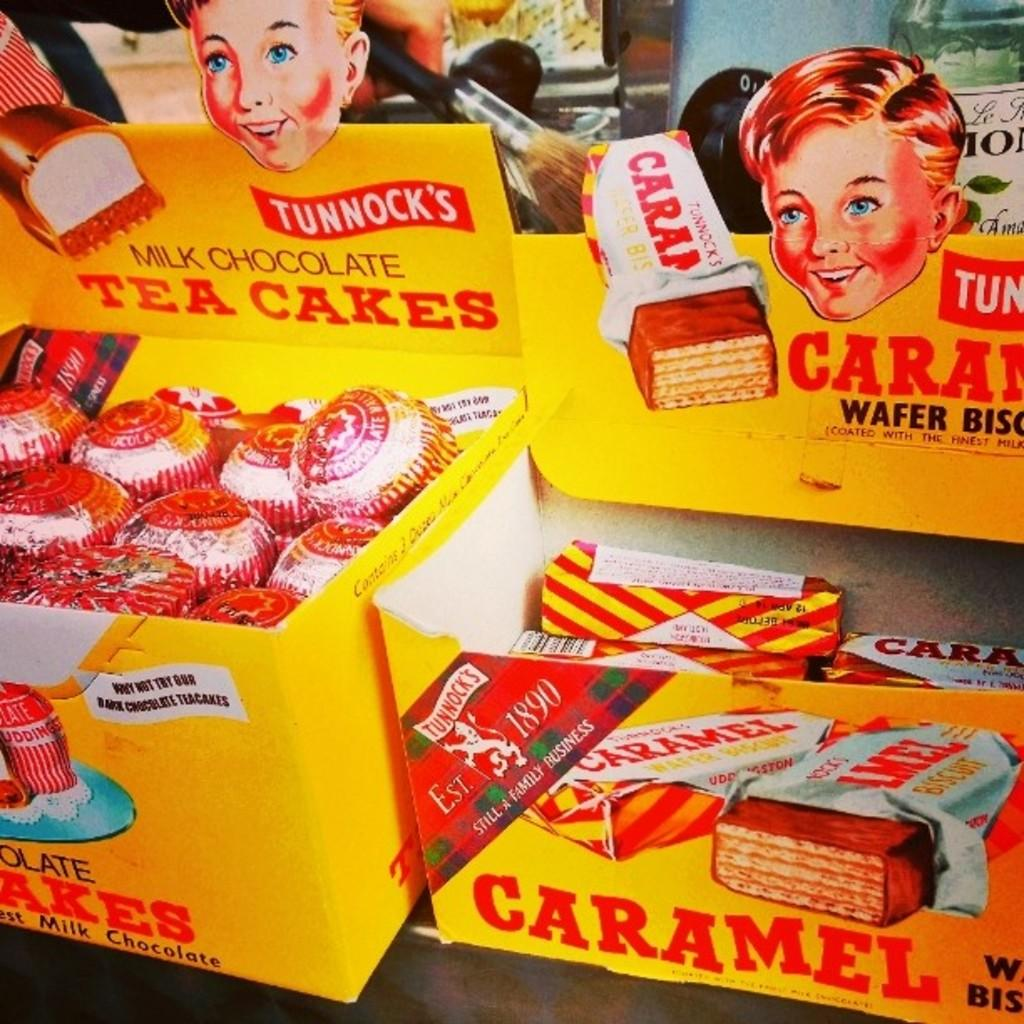What type of food items are present in the image? There are tea cakes and wafer biscuits in the image. What else can be seen in the image besides the food items? There are boxes in the image. How does the lace on the tea cakes affect their taste in the image? There is no lace present on the tea cakes in the image, so it cannot affect their taste. 